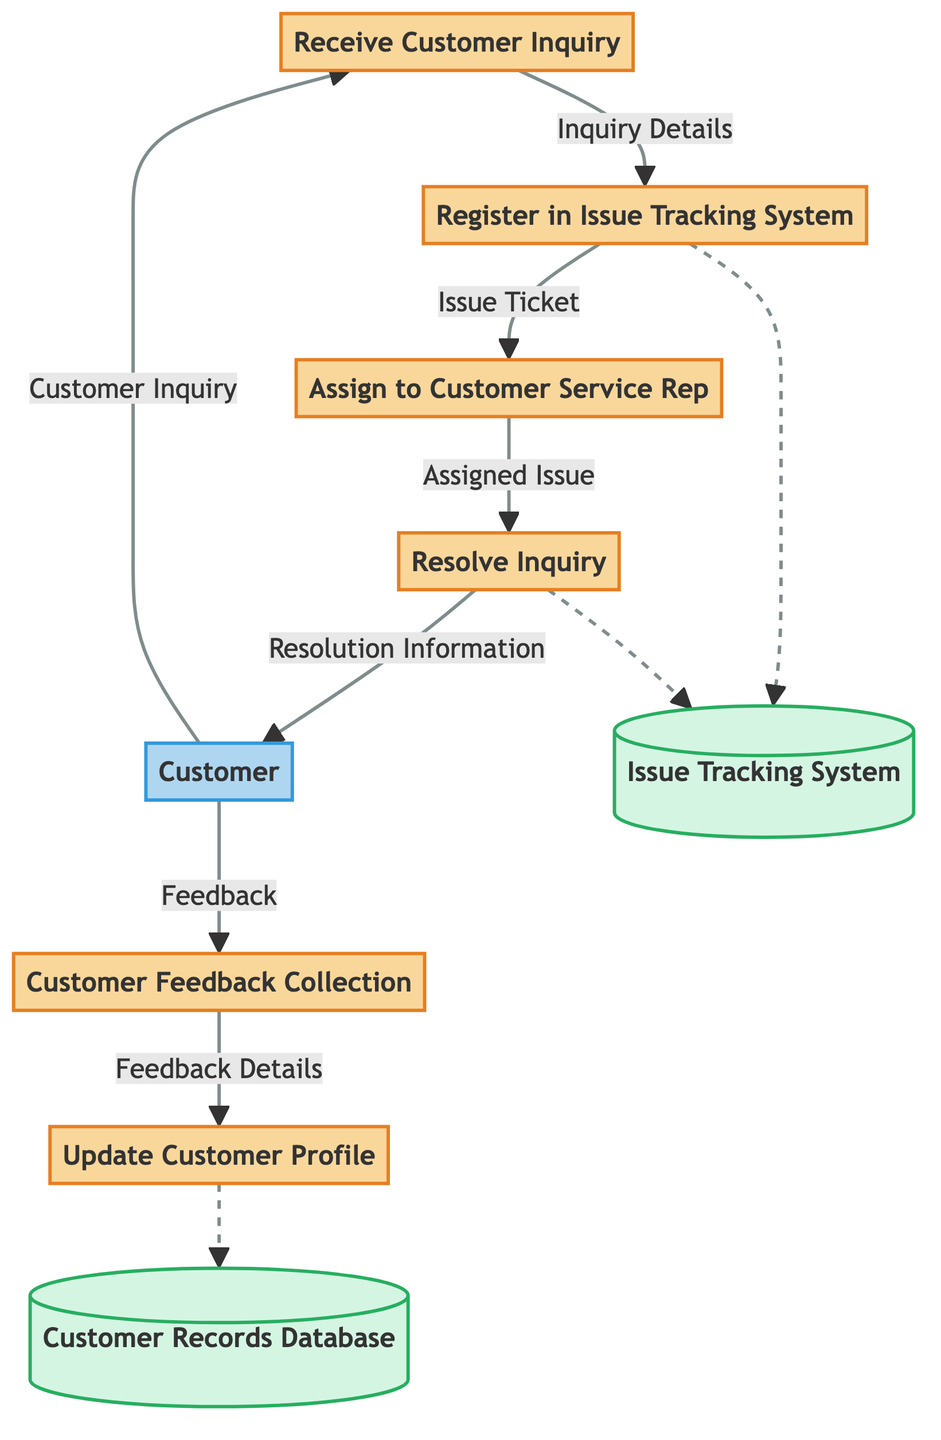What is the first process in the diagram? The first process in the diagram is labeled "Receive Customer Inquiry," as indicated by the order of the processes listed from top to bottom.
Answer: Receive Customer Inquiry How many processes are shown in the diagram? The diagram includes six distinct processes as enumerated in the "processes" section of the data.
Answer: 6 What is the source of the "Inquiry Details" data flow? The "Inquiry Details" data flow originates from the "Receive Customer Inquiry" process, as it is the source node that leads to this specific data flow.
Answer: Receive Customer Inquiry What is the final outcome received by the customer? The diagram indicates that the final outcome received by the customer is "Resolution Information," which comes directly from the "Resolve Inquiry" process.
Answer: Resolution Information What feedback action follows after a customer inquiry is resolved? Following the resolution of the inquiry, the customer is prompted to participate in "Customer Feedback Collection" as per the flow identified in the diagram.
Answer: Customer Feedback Collection Which data store is associated with the issue tracking? The data store specifically associated with issue tracking is the "Issue Tracking System," which is referenced in the data flow connections throughout the diagram.
Answer: Issue Tracking System Which external entity initiates the process? The external entity that initiates the process is the "Customer," who starts the flow by submitting a "Customer Inquiry."
Answer: Customer What data flow connects the "Customer Feedback Collection" to another process? The data flow that connects the "Customer Feedback Collection" to another process is called "Feedback Details," leading to the "Update Customer Profile" process.
Answer: Feedback Details How many data flows are represented in the diagram? The diagram contains a total of seven distinct data flows connecting the relevant processes and entities.
Answer: 7 